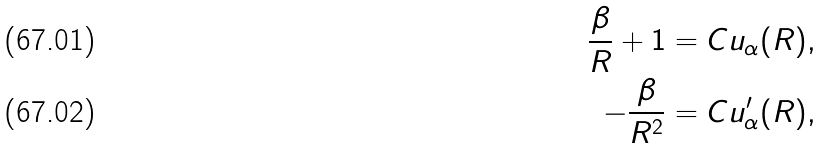<formula> <loc_0><loc_0><loc_500><loc_500>\frac { \beta } { R } + 1 & = C u _ { \alpha } ( R ) , \\ - \frac { \beta } { R ^ { 2 } } & = C u ^ { \prime } _ { \alpha } ( R ) ,</formula> 